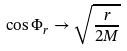<formula> <loc_0><loc_0><loc_500><loc_500>\cos \Phi _ { r } \rightarrow \sqrt { \frac { r } { 2 M } }</formula> 